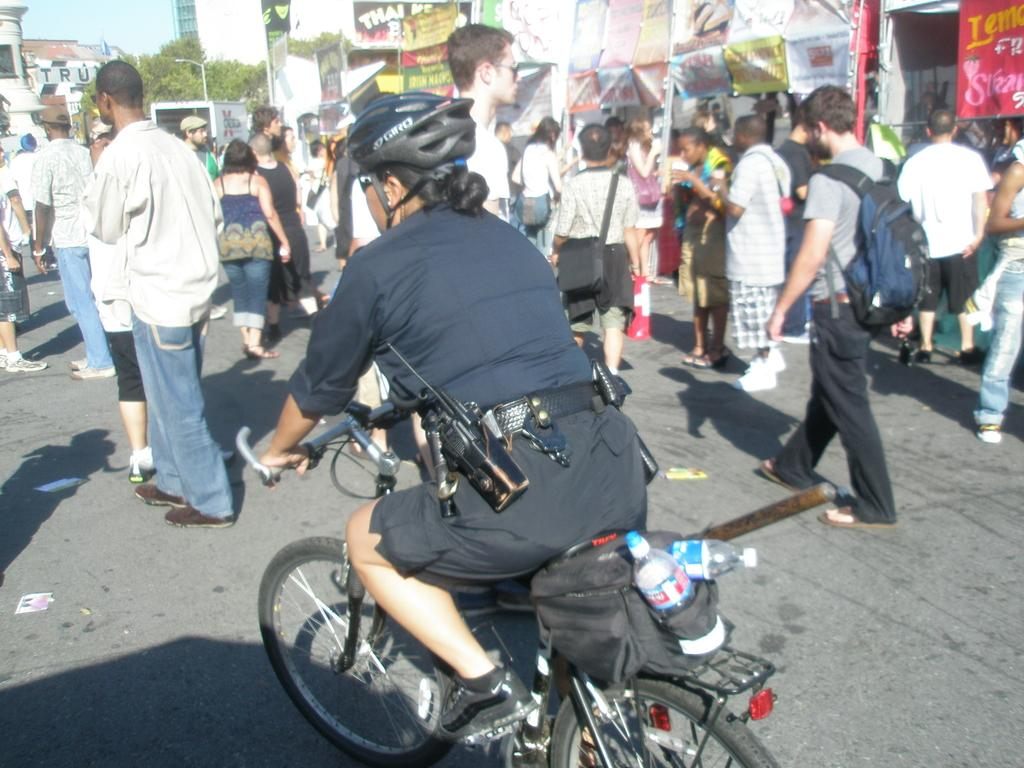Who is the main subject in the image? There is a woman in the image. What is the woman doing in the image? The woman is riding a bicycle. What else can be seen on the road in the image? There are people walking on the road. What items are attached to the bicycle? There are water bottles on the bicycle. What advice does the woman on the bicycle give to the people walking on the road in the image? There is no indication in the image that the woman is giving advice to the people walking on the road. What type of butter can be seen on the bicycle in the image? There is no butter present in the image; only the woman, bicycle, water bottles, and people walking on the road are visible. 